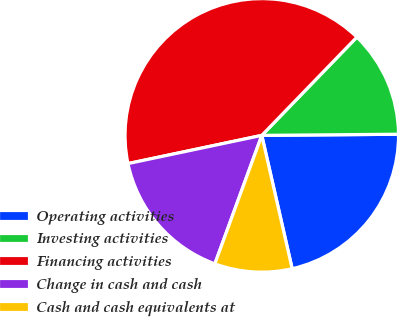Convert chart. <chart><loc_0><loc_0><loc_500><loc_500><pie_chart><fcel>Operating activities<fcel>Investing activities<fcel>Financing activities<fcel>Change in cash and cash<fcel>Cash and cash equivalents at<nl><fcel>21.57%<fcel>12.63%<fcel>40.55%<fcel>16.12%<fcel>9.14%<nl></chart> 